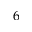<formula> <loc_0><loc_0><loc_500><loc_500>6</formula> 